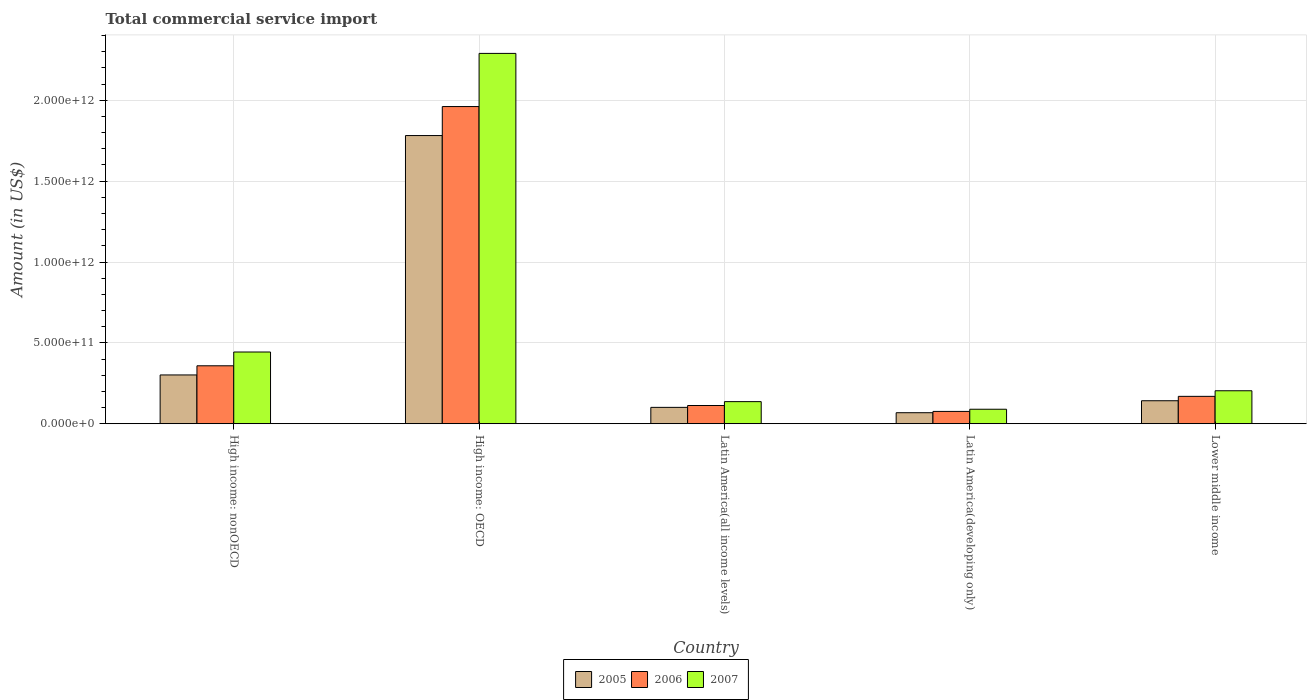How many different coloured bars are there?
Your answer should be very brief. 3. Are the number of bars on each tick of the X-axis equal?
Keep it short and to the point. Yes. How many bars are there on the 4th tick from the left?
Provide a short and direct response. 3. What is the label of the 3rd group of bars from the left?
Your response must be concise. Latin America(all income levels). What is the total commercial service import in 2007 in Latin America(developing only)?
Your response must be concise. 8.96e+1. Across all countries, what is the maximum total commercial service import in 2007?
Your answer should be compact. 2.29e+12. Across all countries, what is the minimum total commercial service import in 2007?
Ensure brevity in your answer.  8.96e+1. In which country was the total commercial service import in 2005 maximum?
Your answer should be compact. High income: OECD. In which country was the total commercial service import in 2005 minimum?
Ensure brevity in your answer.  Latin America(developing only). What is the total total commercial service import in 2006 in the graph?
Your response must be concise. 2.68e+12. What is the difference between the total commercial service import in 2007 in High income: nonOECD and that in Lower middle income?
Keep it short and to the point. 2.40e+11. What is the difference between the total commercial service import in 2007 in High income: nonOECD and the total commercial service import in 2005 in High income: OECD?
Your answer should be very brief. -1.34e+12. What is the average total commercial service import in 2005 per country?
Make the answer very short. 4.79e+11. What is the difference between the total commercial service import of/in 2007 and total commercial service import of/in 2005 in Lower middle income?
Offer a terse response. 6.17e+1. In how many countries, is the total commercial service import in 2007 greater than 1000000000000 US$?
Your answer should be very brief. 1. What is the ratio of the total commercial service import in 2006 in High income: nonOECD to that in Latin America(developing only)?
Ensure brevity in your answer.  4.7. Is the difference between the total commercial service import in 2007 in High income: OECD and High income: nonOECD greater than the difference between the total commercial service import in 2005 in High income: OECD and High income: nonOECD?
Your answer should be compact. Yes. What is the difference between the highest and the second highest total commercial service import in 2007?
Offer a very short reply. -2.40e+11. What is the difference between the highest and the lowest total commercial service import in 2006?
Provide a short and direct response. 1.89e+12. Is the sum of the total commercial service import in 2007 in High income: nonOECD and Lower middle income greater than the maximum total commercial service import in 2005 across all countries?
Ensure brevity in your answer.  No. What does the 1st bar from the left in High income: OECD represents?
Ensure brevity in your answer.  2005. What does the 2nd bar from the right in Lower middle income represents?
Your response must be concise. 2006. Is it the case that in every country, the sum of the total commercial service import in 2005 and total commercial service import in 2006 is greater than the total commercial service import in 2007?
Provide a short and direct response. Yes. How many bars are there?
Keep it short and to the point. 15. What is the difference between two consecutive major ticks on the Y-axis?
Offer a very short reply. 5.00e+11. Does the graph contain any zero values?
Your response must be concise. No. Does the graph contain grids?
Offer a terse response. Yes. How many legend labels are there?
Your response must be concise. 3. How are the legend labels stacked?
Give a very brief answer. Horizontal. What is the title of the graph?
Make the answer very short. Total commercial service import. Does "1975" appear as one of the legend labels in the graph?
Offer a terse response. No. What is the label or title of the Y-axis?
Keep it short and to the point. Amount (in US$). What is the Amount (in US$) in 2005 in High income: nonOECD?
Ensure brevity in your answer.  3.02e+11. What is the Amount (in US$) in 2006 in High income: nonOECD?
Keep it short and to the point. 3.58e+11. What is the Amount (in US$) of 2007 in High income: nonOECD?
Your answer should be very brief. 4.44e+11. What is the Amount (in US$) in 2005 in High income: OECD?
Ensure brevity in your answer.  1.78e+12. What is the Amount (in US$) of 2006 in High income: OECD?
Offer a terse response. 1.96e+12. What is the Amount (in US$) of 2007 in High income: OECD?
Offer a very short reply. 2.29e+12. What is the Amount (in US$) of 2005 in Latin America(all income levels)?
Give a very brief answer. 1.01e+11. What is the Amount (in US$) in 2006 in Latin America(all income levels)?
Provide a short and direct response. 1.13e+11. What is the Amount (in US$) of 2007 in Latin America(all income levels)?
Make the answer very short. 1.37e+11. What is the Amount (in US$) of 2005 in Latin America(developing only)?
Your answer should be compact. 6.81e+1. What is the Amount (in US$) in 2006 in Latin America(developing only)?
Offer a very short reply. 7.62e+1. What is the Amount (in US$) of 2007 in Latin America(developing only)?
Provide a short and direct response. 8.96e+1. What is the Amount (in US$) in 2005 in Lower middle income?
Provide a succinct answer. 1.42e+11. What is the Amount (in US$) in 2006 in Lower middle income?
Your response must be concise. 1.69e+11. What is the Amount (in US$) of 2007 in Lower middle income?
Offer a terse response. 2.04e+11. Across all countries, what is the maximum Amount (in US$) in 2005?
Give a very brief answer. 1.78e+12. Across all countries, what is the maximum Amount (in US$) of 2006?
Keep it short and to the point. 1.96e+12. Across all countries, what is the maximum Amount (in US$) of 2007?
Your answer should be very brief. 2.29e+12. Across all countries, what is the minimum Amount (in US$) of 2005?
Provide a succinct answer. 6.81e+1. Across all countries, what is the minimum Amount (in US$) in 2006?
Ensure brevity in your answer.  7.62e+1. Across all countries, what is the minimum Amount (in US$) in 2007?
Offer a very short reply. 8.96e+1. What is the total Amount (in US$) in 2005 in the graph?
Make the answer very short. 2.40e+12. What is the total Amount (in US$) of 2006 in the graph?
Provide a succinct answer. 2.68e+12. What is the total Amount (in US$) in 2007 in the graph?
Your answer should be very brief. 3.16e+12. What is the difference between the Amount (in US$) in 2005 in High income: nonOECD and that in High income: OECD?
Offer a very short reply. -1.48e+12. What is the difference between the Amount (in US$) in 2006 in High income: nonOECD and that in High income: OECD?
Give a very brief answer. -1.60e+12. What is the difference between the Amount (in US$) in 2007 in High income: nonOECD and that in High income: OECD?
Ensure brevity in your answer.  -1.85e+12. What is the difference between the Amount (in US$) in 2005 in High income: nonOECD and that in Latin America(all income levels)?
Make the answer very short. 2.00e+11. What is the difference between the Amount (in US$) in 2006 in High income: nonOECD and that in Latin America(all income levels)?
Your answer should be very brief. 2.46e+11. What is the difference between the Amount (in US$) of 2007 in High income: nonOECD and that in Latin America(all income levels)?
Your answer should be very brief. 3.07e+11. What is the difference between the Amount (in US$) in 2005 in High income: nonOECD and that in Latin America(developing only)?
Provide a short and direct response. 2.34e+11. What is the difference between the Amount (in US$) of 2006 in High income: nonOECD and that in Latin America(developing only)?
Your response must be concise. 2.82e+11. What is the difference between the Amount (in US$) of 2007 in High income: nonOECD and that in Latin America(developing only)?
Ensure brevity in your answer.  3.54e+11. What is the difference between the Amount (in US$) of 2005 in High income: nonOECD and that in Lower middle income?
Give a very brief answer. 1.59e+11. What is the difference between the Amount (in US$) in 2006 in High income: nonOECD and that in Lower middle income?
Make the answer very short. 1.89e+11. What is the difference between the Amount (in US$) in 2007 in High income: nonOECD and that in Lower middle income?
Your response must be concise. 2.40e+11. What is the difference between the Amount (in US$) of 2005 in High income: OECD and that in Latin America(all income levels)?
Ensure brevity in your answer.  1.68e+12. What is the difference between the Amount (in US$) of 2006 in High income: OECD and that in Latin America(all income levels)?
Ensure brevity in your answer.  1.85e+12. What is the difference between the Amount (in US$) of 2007 in High income: OECD and that in Latin America(all income levels)?
Keep it short and to the point. 2.15e+12. What is the difference between the Amount (in US$) in 2005 in High income: OECD and that in Latin America(developing only)?
Make the answer very short. 1.71e+12. What is the difference between the Amount (in US$) of 2006 in High income: OECD and that in Latin America(developing only)?
Provide a short and direct response. 1.89e+12. What is the difference between the Amount (in US$) of 2007 in High income: OECD and that in Latin America(developing only)?
Provide a succinct answer. 2.20e+12. What is the difference between the Amount (in US$) of 2005 in High income: OECD and that in Lower middle income?
Offer a terse response. 1.64e+12. What is the difference between the Amount (in US$) of 2006 in High income: OECD and that in Lower middle income?
Your response must be concise. 1.79e+12. What is the difference between the Amount (in US$) of 2007 in High income: OECD and that in Lower middle income?
Keep it short and to the point. 2.09e+12. What is the difference between the Amount (in US$) in 2005 in Latin America(all income levels) and that in Latin America(developing only)?
Ensure brevity in your answer.  3.31e+1. What is the difference between the Amount (in US$) of 2006 in Latin America(all income levels) and that in Latin America(developing only)?
Ensure brevity in your answer.  3.65e+1. What is the difference between the Amount (in US$) of 2007 in Latin America(all income levels) and that in Latin America(developing only)?
Make the answer very short. 4.71e+1. What is the difference between the Amount (in US$) in 2005 in Latin America(all income levels) and that in Lower middle income?
Give a very brief answer. -4.10e+1. What is the difference between the Amount (in US$) of 2006 in Latin America(all income levels) and that in Lower middle income?
Provide a succinct answer. -5.67e+1. What is the difference between the Amount (in US$) in 2007 in Latin America(all income levels) and that in Lower middle income?
Give a very brief answer. -6.73e+1. What is the difference between the Amount (in US$) of 2005 in Latin America(developing only) and that in Lower middle income?
Provide a succinct answer. -7.41e+1. What is the difference between the Amount (in US$) in 2006 in Latin America(developing only) and that in Lower middle income?
Give a very brief answer. -9.31e+1. What is the difference between the Amount (in US$) in 2007 in Latin America(developing only) and that in Lower middle income?
Your response must be concise. -1.14e+11. What is the difference between the Amount (in US$) of 2005 in High income: nonOECD and the Amount (in US$) of 2006 in High income: OECD?
Ensure brevity in your answer.  -1.66e+12. What is the difference between the Amount (in US$) in 2005 in High income: nonOECD and the Amount (in US$) in 2007 in High income: OECD?
Your response must be concise. -1.99e+12. What is the difference between the Amount (in US$) in 2006 in High income: nonOECD and the Amount (in US$) in 2007 in High income: OECD?
Ensure brevity in your answer.  -1.93e+12. What is the difference between the Amount (in US$) of 2005 in High income: nonOECD and the Amount (in US$) of 2006 in Latin America(all income levels)?
Provide a short and direct response. 1.89e+11. What is the difference between the Amount (in US$) in 2005 in High income: nonOECD and the Amount (in US$) in 2007 in Latin America(all income levels)?
Give a very brief answer. 1.65e+11. What is the difference between the Amount (in US$) in 2006 in High income: nonOECD and the Amount (in US$) in 2007 in Latin America(all income levels)?
Keep it short and to the point. 2.22e+11. What is the difference between the Amount (in US$) in 2005 in High income: nonOECD and the Amount (in US$) in 2006 in Latin America(developing only)?
Offer a terse response. 2.25e+11. What is the difference between the Amount (in US$) in 2005 in High income: nonOECD and the Amount (in US$) in 2007 in Latin America(developing only)?
Your answer should be very brief. 2.12e+11. What is the difference between the Amount (in US$) of 2006 in High income: nonOECD and the Amount (in US$) of 2007 in Latin America(developing only)?
Provide a short and direct response. 2.69e+11. What is the difference between the Amount (in US$) of 2005 in High income: nonOECD and the Amount (in US$) of 2006 in Lower middle income?
Offer a terse response. 1.32e+11. What is the difference between the Amount (in US$) in 2005 in High income: nonOECD and the Amount (in US$) in 2007 in Lower middle income?
Provide a short and direct response. 9.77e+1. What is the difference between the Amount (in US$) in 2006 in High income: nonOECD and the Amount (in US$) in 2007 in Lower middle income?
Make the answer very short. 1.54e+11. What is the difference between the Amount (in US$) in 2005 in High income: OECD and the Amount (in US$) in 2006 in Latin America(all income levels)?
Give a very brief answer. 1.67e+12. What is the difference between the Amount (in US$) in 2005 in High income: OECD and the Amount (in US$) in 2007 in Latin America(all income levels)?
Your answer should be very brief. 1.65e+12. What is the difference between the Amount (in US$) of 2006 in High income: OECD and the Amount (in US$) of 2007 in Latin America(all income levels)?
Give a very brief answer. 1.82e+12. What is the difference between the Amount (in US$) of 2005 in High income: OECD and the Amount (in US$) of 2006 in Latin America(developing only)?
Your answer should be very brief. 1.71e+12. What is the difference between the Amount (in US$) of 2005 in High income: OECD and the Amount (in US$) of 2007 in Latin America(developing only)?
Keep it short and to the point. 1.69e+12. What is the difference between the Amount (in US$) of 2006 in High income: OECD and the Amount (in US$) of 2007 in Latin America(developing only)?
Provide a succinct answer. 1.87e+12. What is the difference between the Amount (in US$) in 2005 in High income: OECD and the Amount (in US$) in 2006 in Lower middle income?
Offer a terse response. 1.61e+12. What is the difference between the Amount (in US$) in 2005 in High income: OECD and the Amount (in US$) in 2007 in Lower middle income?
Offer a very short reply. 1.58e+12. What is the difference between the Amount (in US$) in 2006 in High income: OECD and the Amount (in US$) in 2007 in Lower middle income?
Your response must be concise. 1.76e+12. What is the difference between the Amount (in US$) in 2005 in Latin America(all income levels) and the Amount (in US$) in 2006 in Latin America(developing only)?
Offer a very short reply. 2.50e+1. What is the difference between the Amount (in US$) of 2005 in Latin America(all income levels) and the Amount (in US$) of 2007 in Latin America(developing only)?
Provide a succinct answer. 1.16e+1. What is the difference between the Amount (in US$) of 2006 in Latin America(all income levels) and the Amount (in US$) of 2007 in Latin America(developing only)?
Offer a very short reply. 2.31e+1. What is the difference between the Amount (in US$) in 2005 in Latin America(all income levels) and the Amount (in US$) in 2006 in Lower middle income?
Give a very brief answer. -6.81e+1. What is the difference between the Amount (in US$) in 2005 in Latin America(all income levels) and the Amount (in US$) in 2007 in Lower middle income?
Ensure brevity in your answer.  -1.03e+11. What is the difference between the Amount (in US$) of 2006 in Latin America(all income levels) and the Amount (in US$) of 2007 in Lower middle income?
Offer a very short reply. -9.13e+1. What is the difference between the Amount (in US$) in 2005 in Latin America(developing only) and the Amount (in US$) in 2006 in Lower middle income?
Offer a very short reply. -1.01e+11. What is the difference between the Amount (in US$) of 2005 in Latin America(developing only) and the Amount (in US$) of 2007 in Lower middle income?
Keep it short and to the point. -1.36e+11. What is the difference between the Amount (in US$) in 2006 in Latin America(developing only) and the Amount (in US$) in 2007 in Lower middle income?
Make the answer very short. -1.28e+11. What is the average Amount (in US$) of 2005 per country?
Your response must be concise. 4.79e+11. What is the average Amount (in US$) in 2006 per country?
Keep it short and to the point. 5.36e+11. What is the average Amount (in US$) in 2007 per country?
Offer a terse response. 6.33e+11. What is the difference between the Amount (in US$) of 2005 and Amount (in US$) of 2006 in High income: nonOECD?
Your answer should be very brief. -5.66e+1. What is the difference between the Amount (in US$) in 2005 and Amount (in US$) in 2007 in High income: nonOECD?
Your answer should be very brief. -1.42e+11. What is the difference between the Amount (in US$) of 2006 and Amount (in US$) of 2007 in High income: nonOECD?
Give a very brief answer. -8.52e+1. What is the difference between the Amount (in US$) in 2005 and Amount (in US$) in 2006 in High income: OECD?
Provide a succinct answer. -1.79e+11. What is the difference between the Amount (in US$) of 2005 and Amount (in US$) of 2007 in High income: OECD?
Ensure brevity in your answer.  -5.08e+11. What is the difference between the Amount (in US$) of 2006 and Amount (in US$) of 2007 in High income: OECD?
Ensure brevity in your answer.  -3.29e+11. What is the difference between the Amount (in US$) of 2005 and Amount (in US$) of 2006 in Latin America(all income levels)?
Ensure brevity in your answer.  -1.15e+1. What is the difference between the Amount (in US$) of 2005 and Amount (in US$) of 2007 in Latin America(all income levels)?
Make the answer very short. -3.55e+1. What is the difference between the Amount (in US$) in 2006 and Amount (in US$) in 2007 in Latin America(all income levels)?
Your answer should be compact. -2.40e+1. What is the difference between the Amount (in US$) in 2005 and Amount (in US$) in 2006 in Latin America(developing only)?
Your answer should be very brief. -8.08e+09. What is the difference between the Amount (in US$) in 2005 and Amount (in US$) in 2007 in Latin America(developing only)?
Offer a very short reply. -2.15e+1. What is the difference between the Amount (in US$) in 2006 and Amount (in US$) in 2007 in Latin America(developing only)?
Provide a short and direct response. -1.34e+1. What is the difference between the Amount (in US$) of 2005 and Amount (in US$) of 2006 in Lower middle income?
Your answer should be very brief. -2.71e+1. What is the difference between the Amount (in US$) in 2005 and Amount (in US$) in 2007 in Lower middle income?
Offer a very short reply. -6.17e+1. What is the difference between the Amount (in US$) of 2006 and Amount (in US$) of 2007 in Lower middle income?
Give a very brief answer. -3.46e+1. What is the ratio of the Amount (in US$) of 2005 in High income: nonOECD to that in High income: OECD?
Make the answer very short. 0.17. What is the ratio of the Amount (in US$) of 2006 in High income: nonOECD to that in High income: OECD?
Your answer should be compact. 0.18. What is the ratio of the Amount (in US$) in 2007 in High income: nonOECD to that in High income: OECD?
Your answer should be very brief. 0.19. What is the ratio of the Amount (in US$) of 2005 in High income: nonOECD to that in Latin America(all income levels)?
Ensure brevity in your answer.  2.98. What is the ratio of the Amount (in US$) of 2006 in High income: nonOECD to that in Latin America(all income levels)?
Make the answer very short. 3.18. What is the ratio of the Amount (in US$) of 2007 in High income: nonOECD to that in Latin America(all income levels)?
Provide a succinct answer. 3.25. What is the ratio of the Amount (in US$) in 2005 in High income: nonOECD to that in Latin America(developing only)?
Your answer should be compact. 4.43. What is the ratio of the Amount (in US$) in 2006 in High income: nonOECD to that in Latin America(developing only)?
Keep it short and to the point. 4.7. What is the ratio of the Amount (in US$) of 2007 in High income: nonOECD to that in Latin America(developing only)?
Provide a short and direct response. 4.95. What is the ratio of the Amount (in US$) in 2005 in High income: nonOECD to that in Lower middle income?
Provide a short and direct response. 2.12. What is the ratio of the Amount (in US$) in 2006 in High income: nonOECD to that in Lower middle income?
Make the answer very short. 2.12. What is the ratio of the Amount (in US$) of 2007 in High income: nonOECD to that in Lower middle income?
Offer a terse response. 2.17. What is the ratio of the Amount (in US$) of 2005 in High income: OECD to that in Latin America(all income levels)?
Your response must be concise. 17.6. What is the ratio of the Amount (in US$) in 2006 in High income: OECD to that in Latin America(all income levels)?
Your answer should be very brief. 17.4. What is the ratio of the Amount (in US$) in 2007 in High income: OECD to that in Latin America(all income levels)?
Your response must be concise. 16.75. What is the ratio of the Amount (in US$) of 2005 in High income: OECD to that in Latin America(developing only)?
Keep it short and to the point. 26.15. What is the ratio of the Amount (in US$) in 2006 in High income: OECD to that in Latin America(developing only)?
Your answer should be very brief. 25.73. What is the ratio of the Amount (in US$) of 2007 in High income: OECD to that in Latin America(developing only)?
Offer a terse response. 25.55. What is the ratio of the Amount (in US$) of 2005 in High income: OECD to that in Lower middle income?
Your answer should be compact. 12.53. What is the ratio of the Amount (in US$) of 2006 in High income: OECD to that in Lower middle income?
Your answer should be very brief. 11.58. What is the ratio of the Amount (in US$) in 2007 in High income: OECD to that in Lower middle income?
Offer a terse response. 11.23. What is the ratio of the Amount (in US$) of 2005 in Latin America(all income levels) to that in Latin America(developing only)?
Offer a terse response. 1.49. What is the ratio of the Amount (in US$) of 2006 in Latin America(all income levels) to that in Latin America(developing only)?
Ensure brevity in your answer.  1.48. What is the ratio of the Amount (in US$) of 2007 in Latin America(all income levels) to that in Latin America(developing only)?
Provide a short and direct response. 1.53. What is the ratio of the Amount (in US$) in 2005 in Latin America(all income levels) to that in Lower middle income?
Give a very brief answer. 0.71. What is the ratio of the Amount (in US$) in 2006 in Latin America(all income levels) to that in Lower middle income?
Provide a short and direct response. 0.67. What is the ratio of the Amount (in US$) of 2007 in Latin America(all income levels) to that in Lower middle income?
Your answer should be very brief. 0.67. What is the ratio of the Amount (in US$) of 2005 in Latin America(developing only) to that in Lower middle income?
Your answer should be compact. 0.48. What is the ratio of the Amount (in US$) in 2006 in Latin America(developing only) to that in Lower middle income?
Keep it short and to the point. 0.45. What is the ratio of the Amount (in US$) of 2007 in Latin America(developing only) to that in Lower middle income?
Ensure brevity in your answer.  0.44. What is the difference between the highest and the second highest Amount (in US$) in 2005?
Provide a short and direct response. 1.48e+12. What is the difference between the highest and the second highest Amount (in US$) of 2006?
Your response must be concise. 1.60e+12. What is the difference between the highest and the second highest Amount (in US$) of 2007?
Make the answer very short. 1.85e+12. What is the difference between the highest and the lowest Amount (in US$) of 2005?
Make the answer very short. 1.71e+12. What is the difference between the highest and the lowest Amount (in US$) in 2006?
Give a very brief answer. 1.89e+12. What is the difference between the highest and the lowest Amount (in US$) of 2007?
Your answer should be very brief. 2.20e+12. 